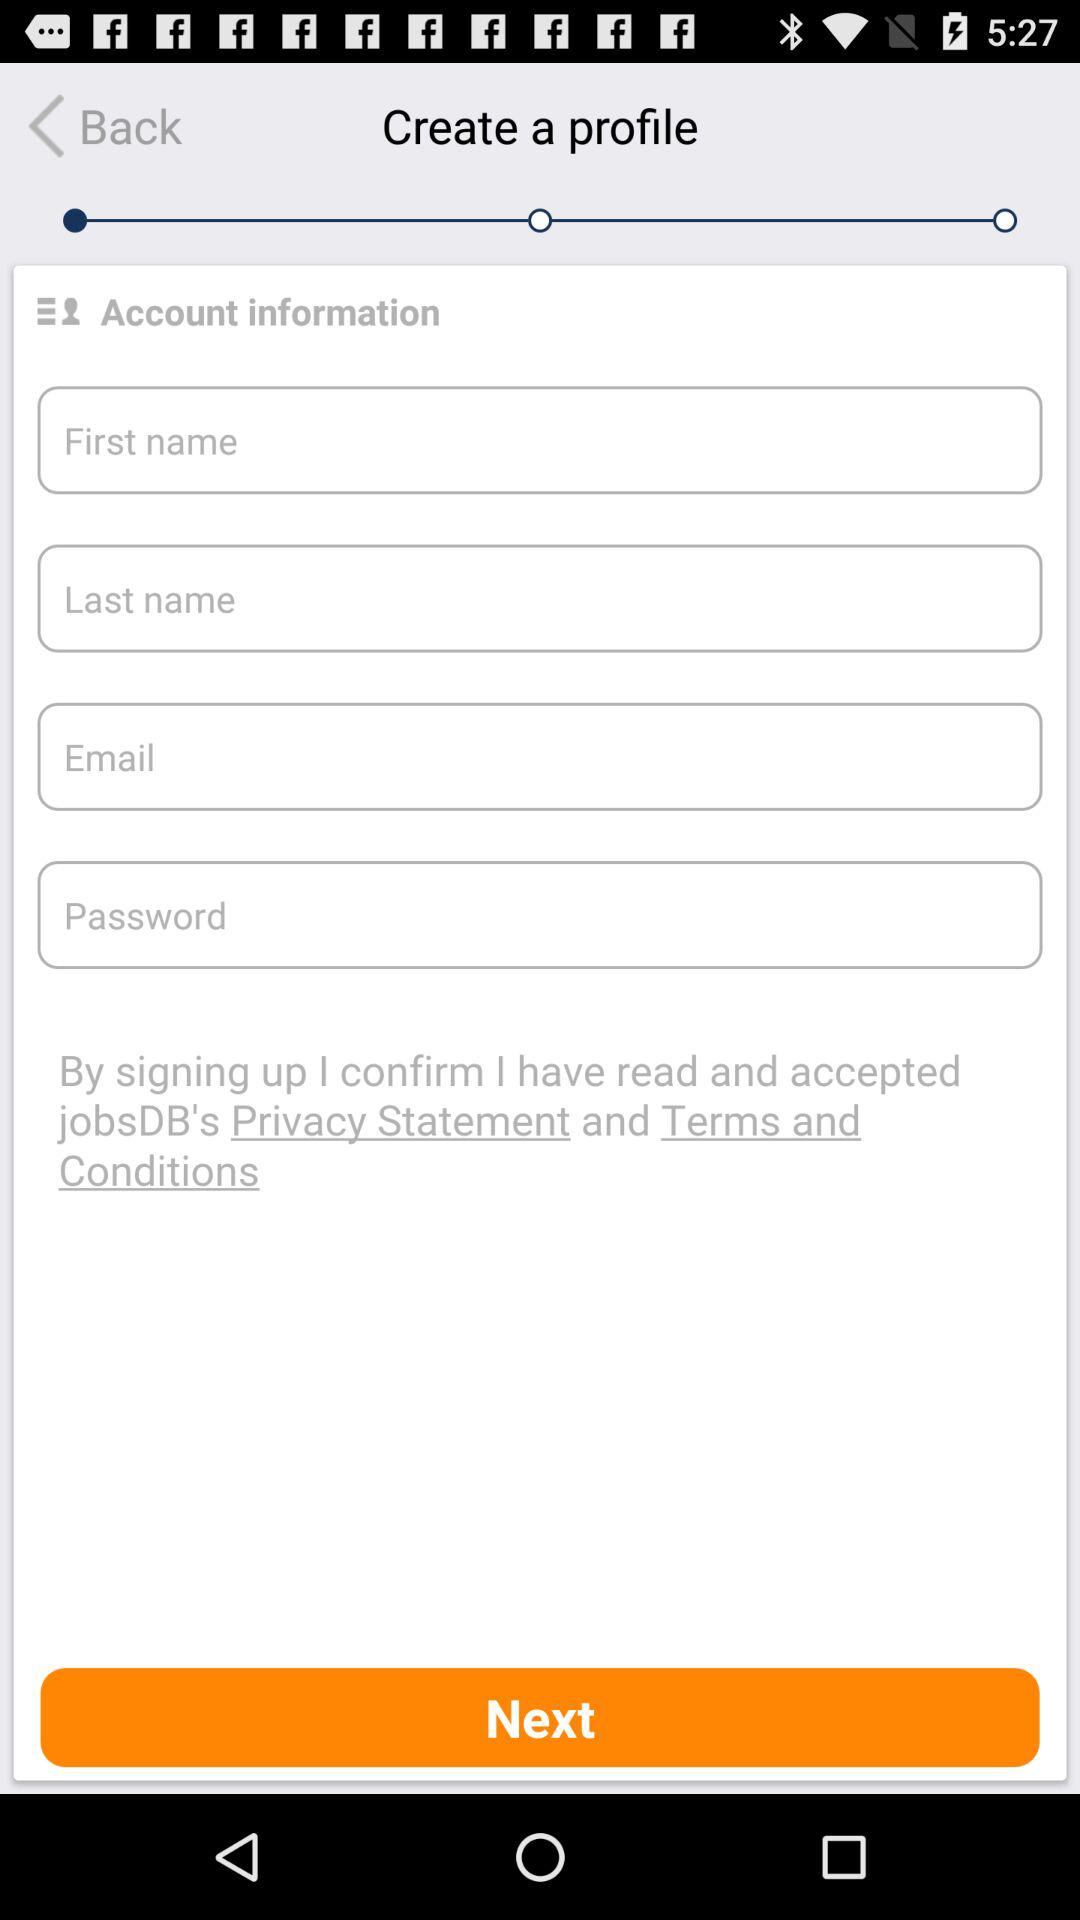How many fields are required to create a profile?
Answer the question using a single word or phrase. 4 